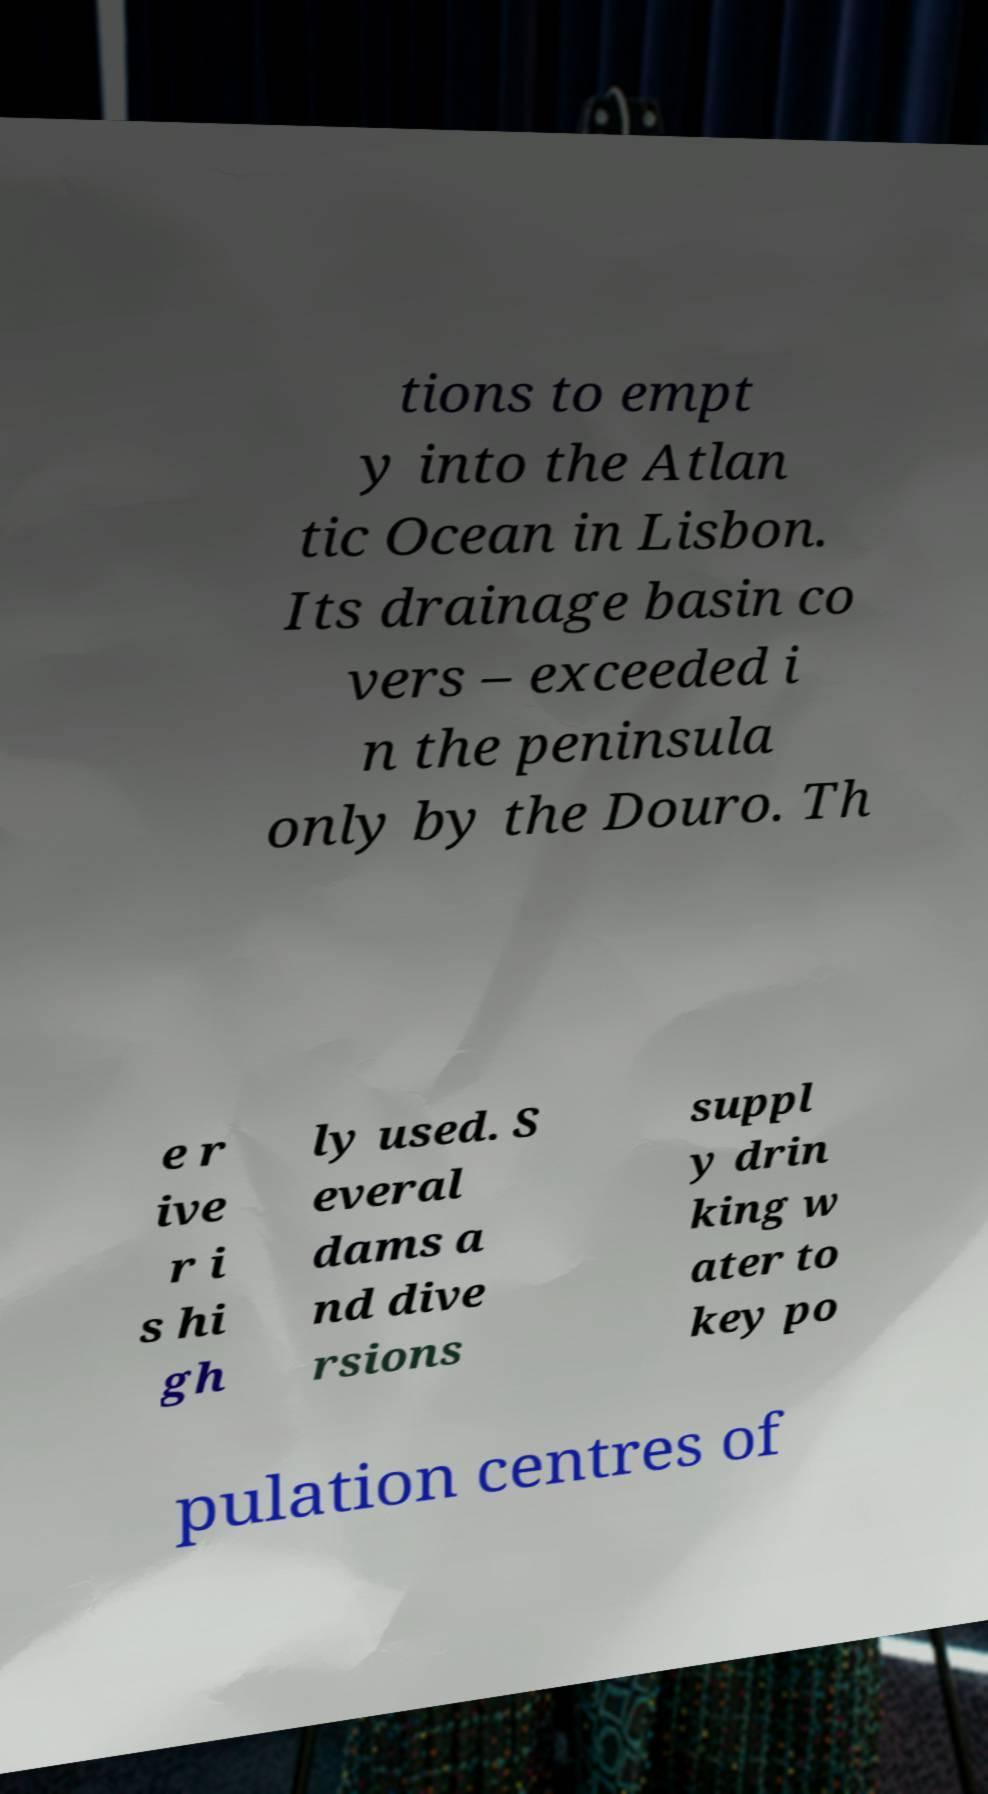For documentation purposes, I need the text within this image transcribed. Could you provide that? tions to empt y into the Atlan tic Ocean in Lisbon. Its drainage basin co vers – exceeded i n the peninsula only by the Douro. Th e r ive r i s hi gh ly used. S everal dams a nd dive rsions suppl y drin king w ater to key po pulation centres of 